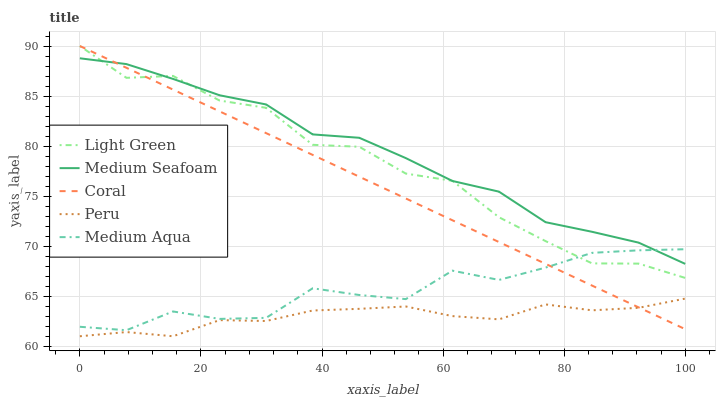Does Peru have the minimum area under the curve?
Answer yes or no. Yes. Does Medium Seafoam have the maximum area under the curve?
Answer yes or no. Yes. Does Coral have the minimum area under the curve?
Answer yes or no. No. Does Coral have the maximum area under the curve?
Answer yes or no. No. Is Coral the smoothest?
Answer yes or no. Yes. Is Light Green the roughest?
Answer yes or no. Yes. Is Medium Aqua the smoothest?
Answer yes or no. No. Is Medium Aqua the roughest?
Answer yes or no. No. Does Peru have the lowest value?
Answer yes or no. Yes. Does Coral have the lowest value?
Answer yes or no. No. Does Light Green have the highest value?
Answer yes or no. Yes. Does Medium Aqua have the highest value?
Answer yes or no. No. Is Peru less than Medium Seafoam?
Answer yes or no. Yes. Is Light Green greater than Peru?
Answer yes or no. Yes. Does Light Green intersect Coral?
Answer yes or no. Yes. Is Light Green less than Coral?
Answer yes or no. No. Is Light Green greater than Coral?
Answer yes or no. No. Does Peru intersect Medium Seafoam?
Answer yes or no. No. 